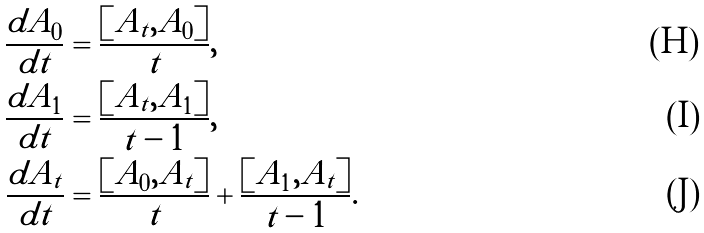<formula> <loc_0><loc_0><loc_500><loc_500>\frac { d A _ { 0 } } { d t } & = \frac { [ A _ { t } , A _ { 0 } ] } { t } , \\ \frac { d A _ { 1 } } { d t } & = \frac { [ A _ { t } , A _ { 1 } ] } { t - 1 } , \\ \frac { d A _ { t } } { d t } & = \frac { [ A _ { 0 } , A _ { t } ] } { t } + \frac { [ A _ { 1 } , A _ { t } ] } { t - 1 } .</formula> 